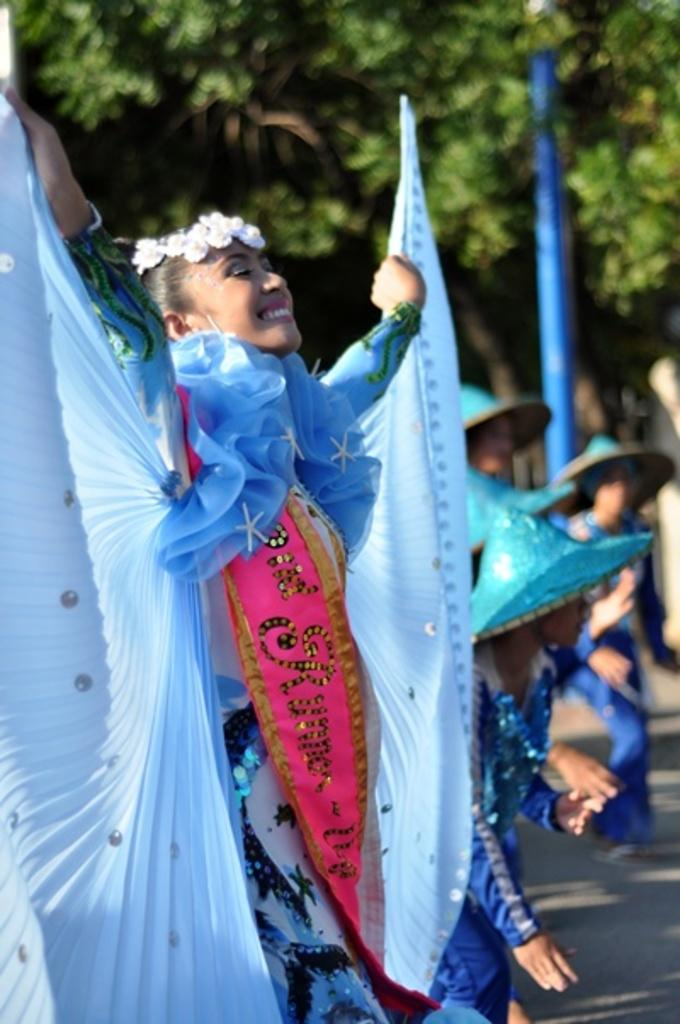What can be seen in the image? There is a group of women in the image. Where are the women located? The women are standing on the road. What is visible in the background of the image? There are trees and a pole in the background of the image. What color is the orange that the women are holding in the image? There is no orange present in the image; the women are not holding any oranges. 